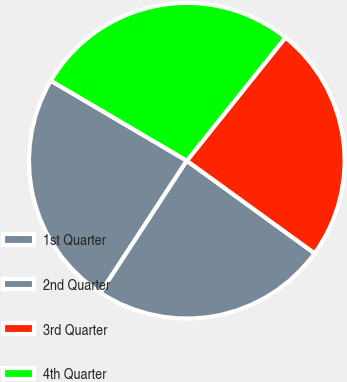Convert chart. <chart><loc_0><loc_0><loc_500><loc_500><pie_chart><fcel>1st Quarter<fcel>2nd Quarter<fcel>3rd Quarter<fcel>4th Quarter<nl><fcel>24.24%<fcel>24.24%<fcel>24.24%<fcel>27.27%<nl></chart> 